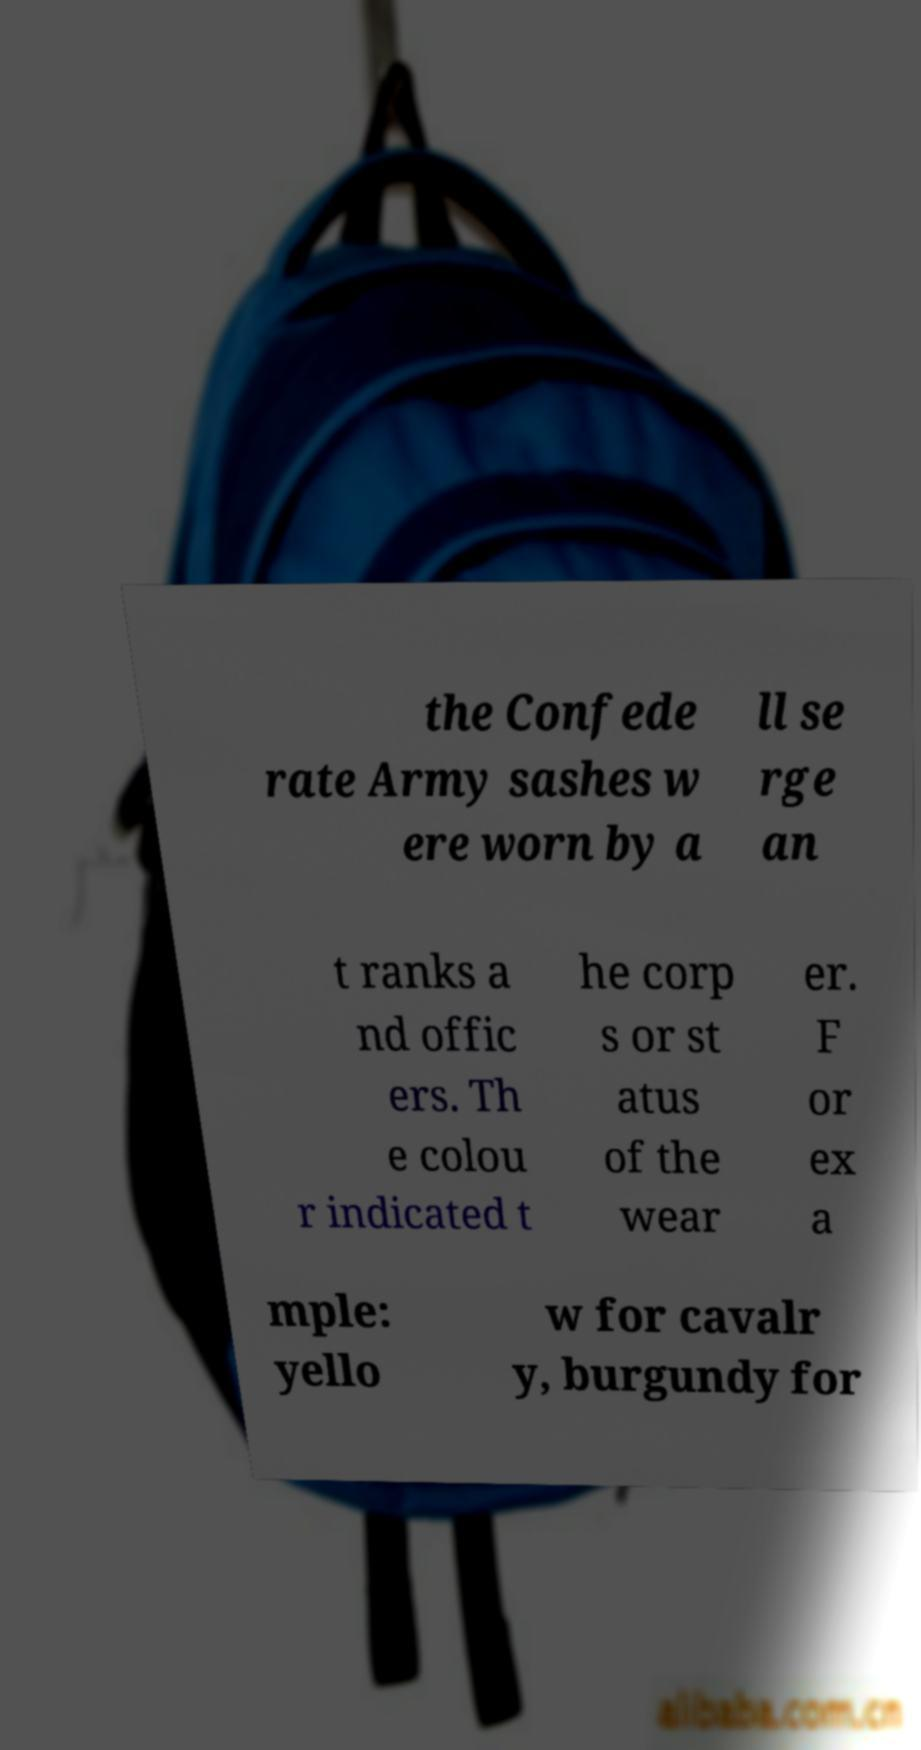I need the written content from this picture converted into text. Can you do that? the Confede rate Army sashes w ere worn by a ll se rge an t ranks a nd offic ers. Th e colou r indicated t he corp s or st atus of the wear er. F or ex a mple: yello w for cavalr y, burgundy for 